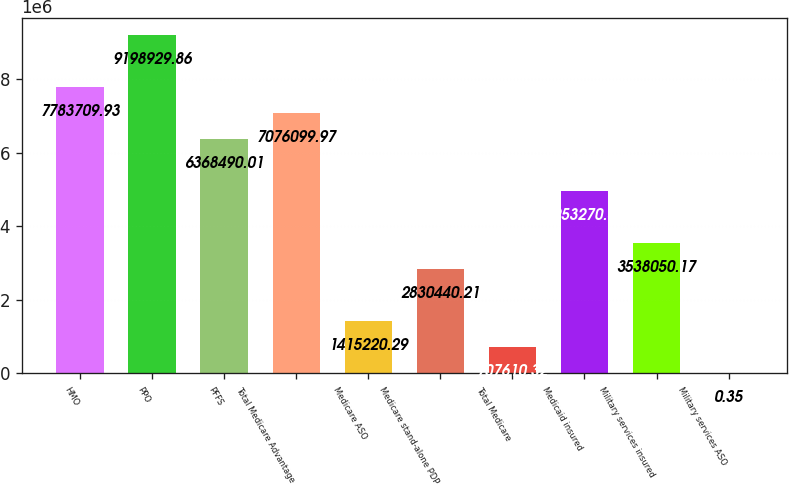<chart> <loc_0><loc_0><loc_500><loc_500><bar_chart><fcel>HMO<fcel>PPO<fcel>PFFS<fcel>Total Medicare Advantage<fcel>Medicare ASO<fcel>Medicare stand-alone PDP<fcel>Total Medicare<fcel>Medicaid insured<fcel>Military services insured<fcel>Military services ASO<nl><fcel>7.78371e+06<fcel>9.19893e+06<fcel>6.36849e+06<fcel>7.0761e+06<fcel>1.41522e+06<fcel>2.83044e+06<fcel>707610<fcel>4.95327e+06<fcel>3.53805e+06<fcel>0.35<nl></chart> 